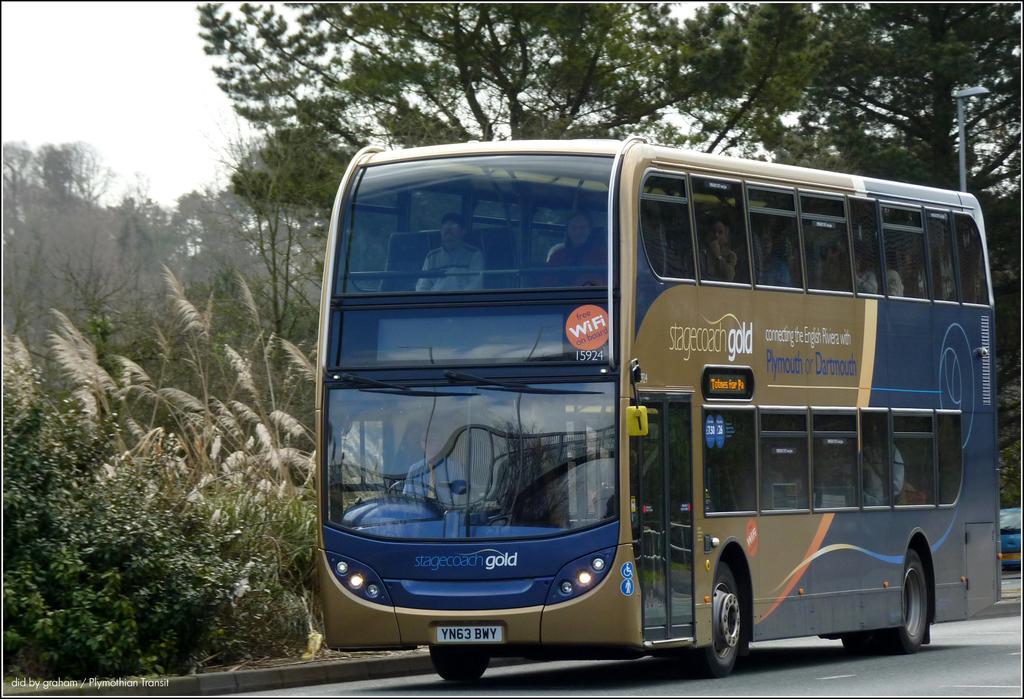Describe this image in one or two sentences. In this picture I can see a Double Decker bus on the road, there are trees, and in the background there is sky and there is a watermark on the image. 